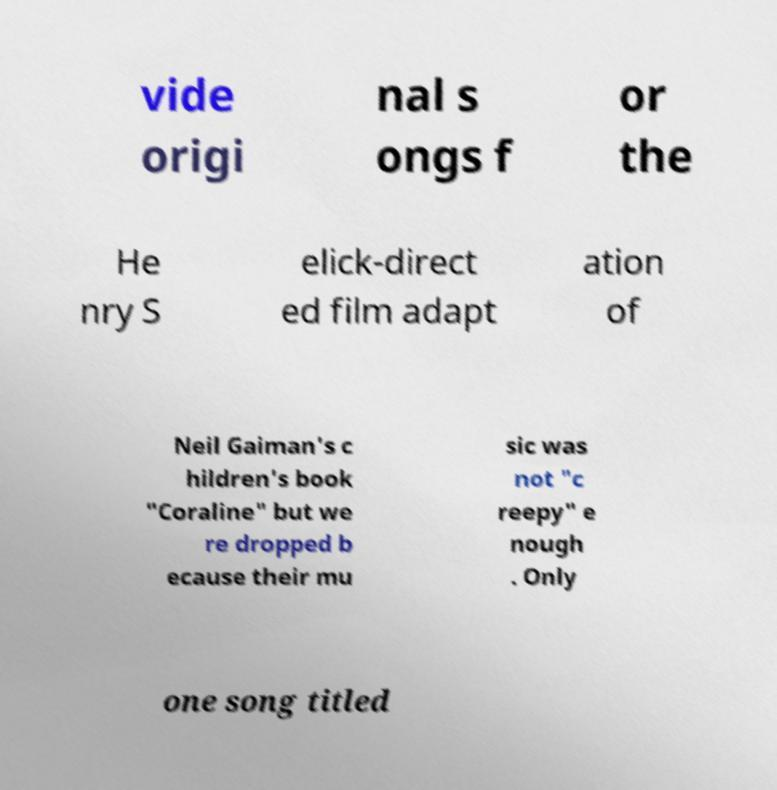Could you assist in decoding the text presented in this image and type it out clearly? vide origi nal s ongs f or the He nry S elick-direct ed film adapt ation of Neil Gaiman's c hildren's book "Coraline" but we re dropped b ecause their mu sic was not "c reepy" e nough . Only one song titled 